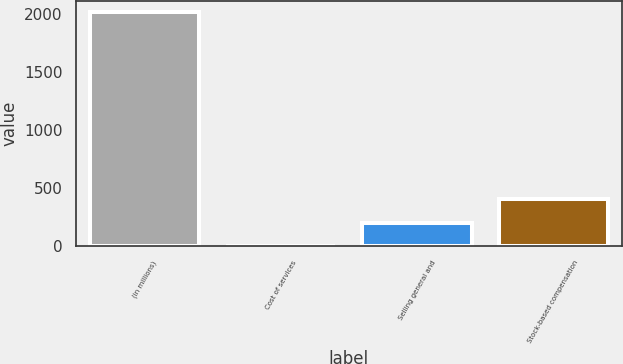Convert chart. <chart><loc_0><loc_0><loc_500><loc_500><bar_chart><fcel>(in millions)<fcel>Cost of services<fcel>Selling general and<fcel>Stock-based compensation<nl><fcel>2009<fcel>2.6<fcel>203.24<fcel>403.88<nl></chart> 